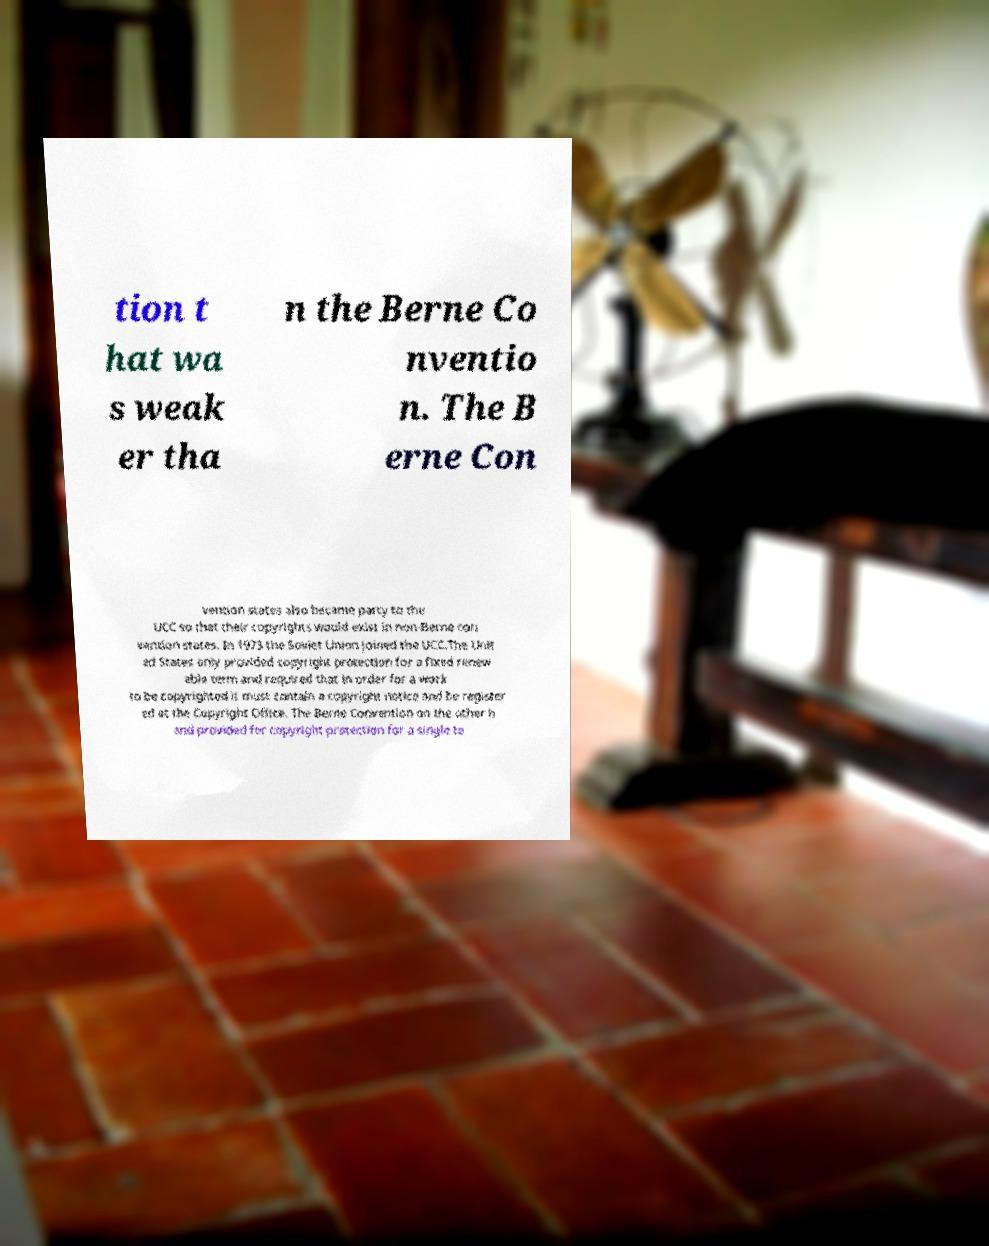Please identify and transcribe the text found in this image. tion t hat wa s weak er tha n the Berne Co nventio n. The B erne Con vention states also became party to the UCC so that their copyrights would exist in non-Berne con vention states. In 1973 the Soviet Union joined the UCC.The Unit ed States only provided copyright protection for a fixed renew able term and required that in order for a work to be copyrighted it must contain a copyright notice and be register ed at the Copyright Office. The Berne Convention on the other h and provided for copyright protection for a single te 